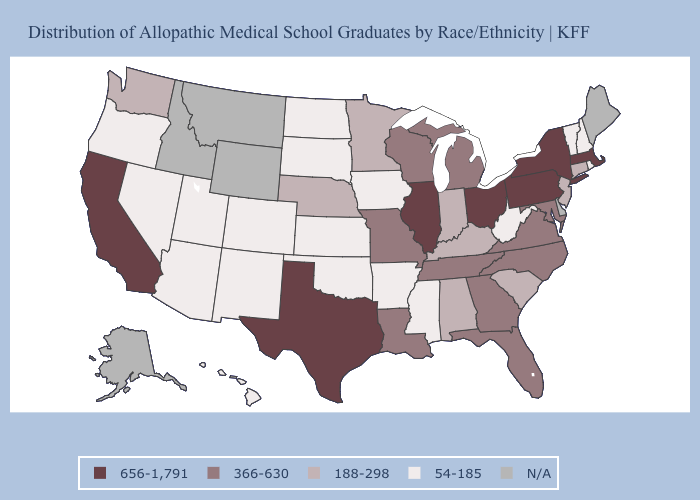Name the states that have a value in the range 656-1,791?
Short answer required. California, Illinois, Massachusetts, New York, Ohio, Pennsylvania, Texas. What is the value of Wisconsin?
Write a very short answer. 366-630. Does the first symbol in the legend represent the smallest category?
Quick response, please. No. What is the value of North Carolina?
Answer briefly. 366-630. Does Indiana have the highest value in the USA?
Concise answer only. No. Which states have the lowest value in the USA?
Give a very brief answer. Arizona, Arkansas, Colorado, Hawaii, Iowa, Kansas, Mississippi, Nevada, New Hampshire, New Mexico, North Dakota, Oklahoma, Oregon, Rhode Island, South Dakota, Utah, Vermont, West Virginia. What is the highest value in states that border North Carolina?
Answer briefly. 366-630. Does Vermont have the lowest value in the USA?
Quick response, please. Yes. What is the lowest value in the MidWest?
Short answer required. 54-185. Name the states that have a value in the range 188-298?
Short answer required. Alabama, Connecticut, Indiana, Kentucky, Minnesota, Nebraska, New Jersey, South Carolina, Washington. Does Oregon have the highest value in the West?
Keep it brief. No. Name the states that have a value in the range 54-185?
Write a very short answer. Arizona, Arkansas, Colorado, Hawaii, Iowa, Kansas, Mississippi, Nevada, New Hampshire, New Mexico, North Dakota, Oklahoma, Oregon, Rhode Island, South Dakota, Utah, Vermont, West Virginia. What is the value of Minnesota?
Short answer required. 188-298. 